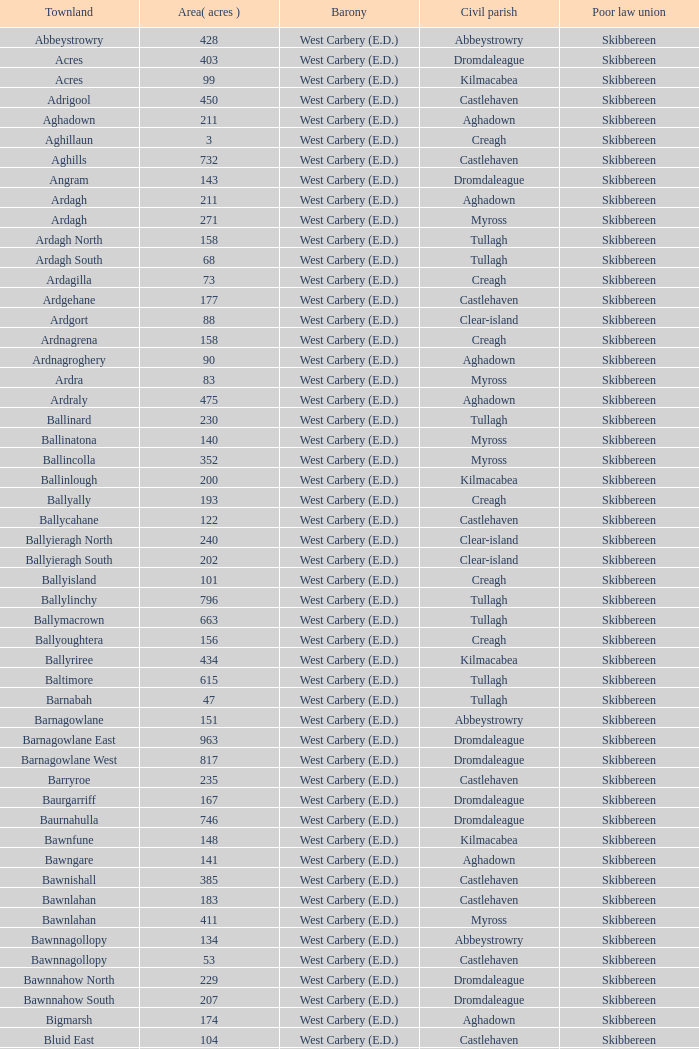What baronies correspond to an area of 276 acres? West Carbery (E.D.). 